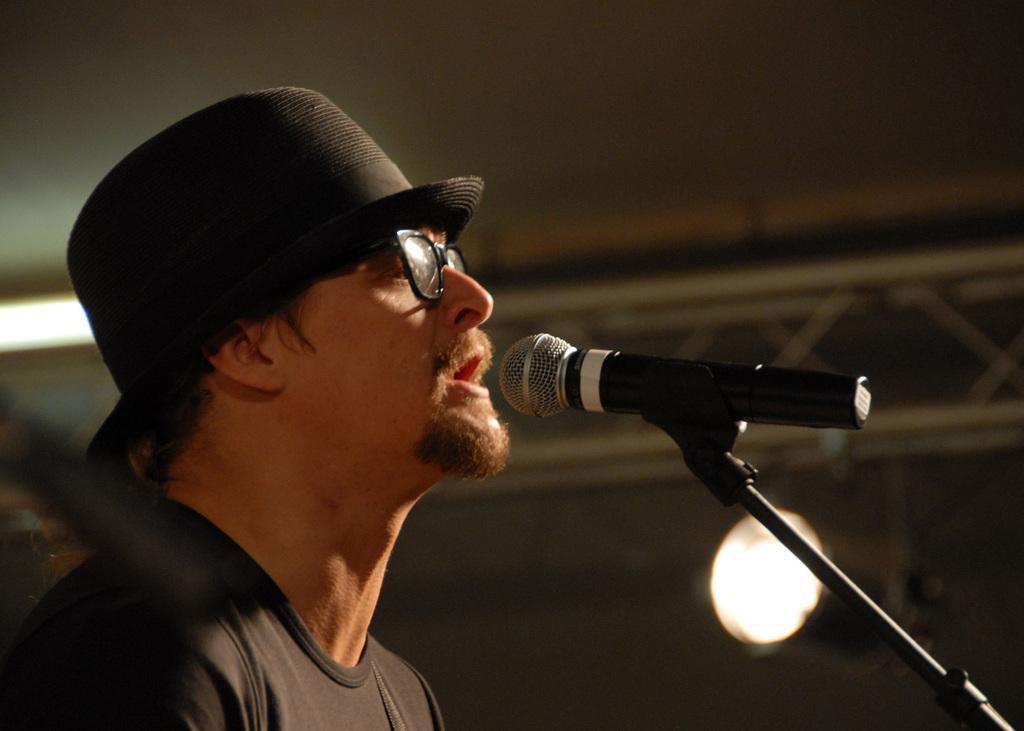In one or two sentences, can you explain what this image depicts? In this image I can see a person wearing a black color shirt and wearing a black color cap on his head and wearing a spectacles and in front of him there is a mike. 